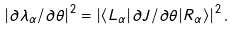<formula> <loc_0><loc_0><loc_500><loc_500>| \partial \lambda _ { \alpha } / \partial \theta | ^ { 2 } = | \langle L _ { \alpha } | \partial J / \partial \theta | R _ { \alpha } \rangle | ^ { 2 } \, .</formula> 